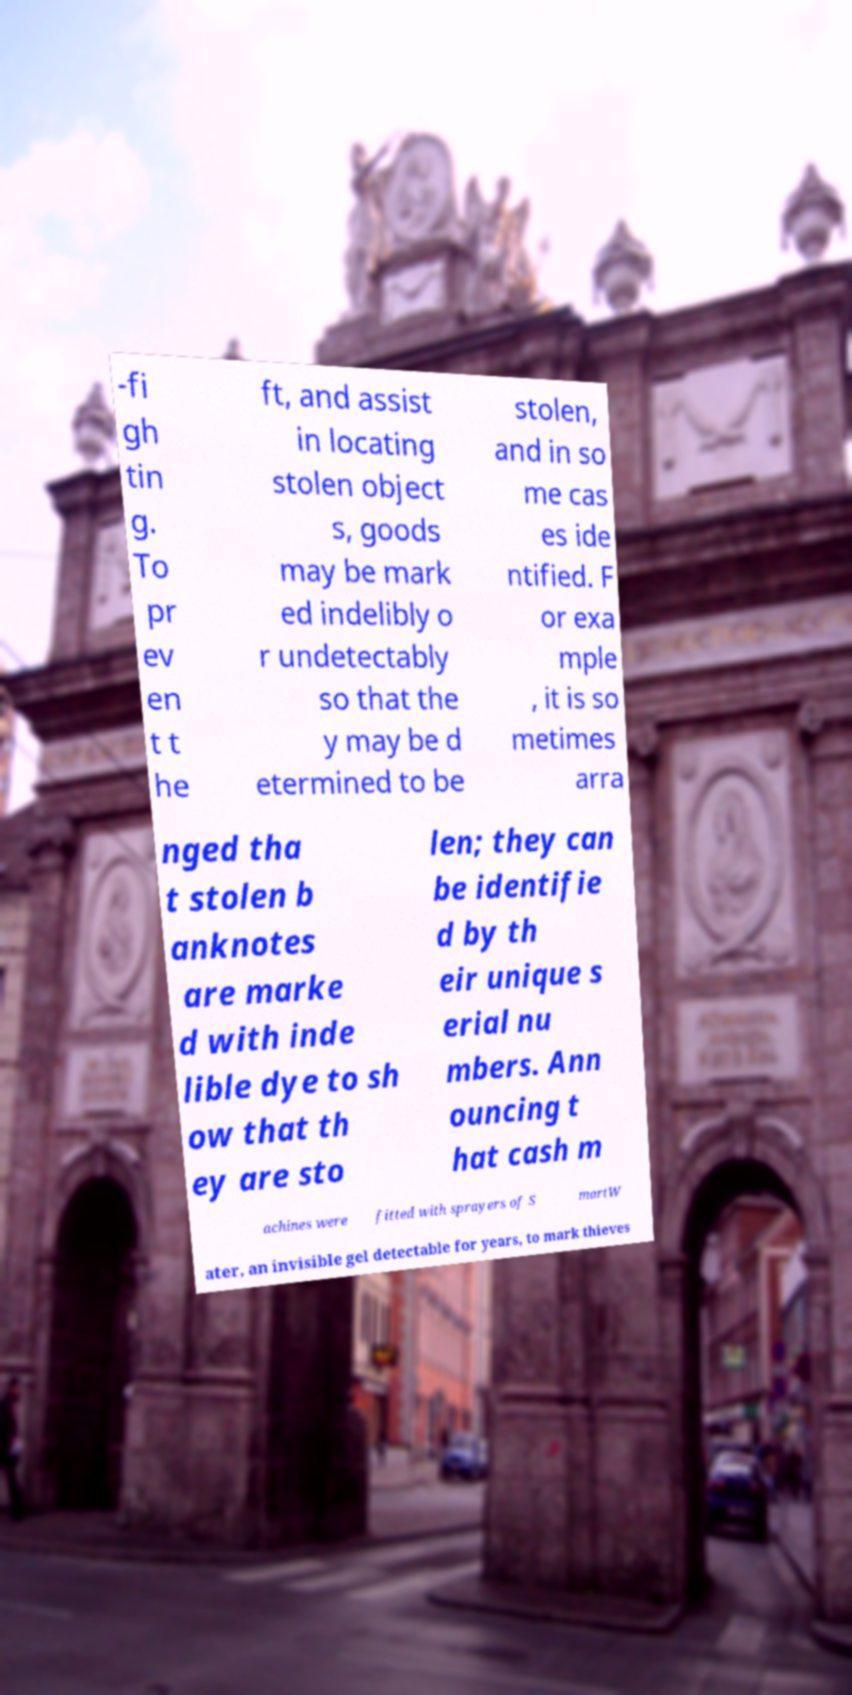Can you read and provide the text displayed in the image?This photo seems to have some interesting text. Can you extract and type it out for me? -fi gh tin g. To pr ev en t t he ft, and assist in locating stolen object s, goods may be mark ed indelibly o r undetectably so that the y may be d etermined to be stolen, and in so me cas es ide ntified. F or exa mple , it is so metimes arra nged tha t stolen b anknotes are marke d with inde lible dye to sh ow that th ey are sto len; they can be identifie d by th eir unique s erial nu mbers. Ann ouncing t hat cash m achines were fitted with sprayers of S martW ater, an invisible gel detectable for years, to mark thieves 